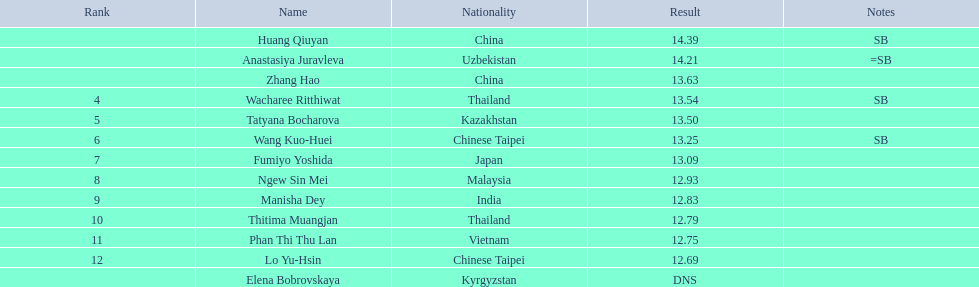What is the number of different nationalities represented by the top 5 athletes? 4. 